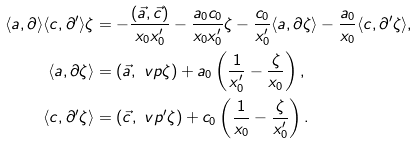<formula> <loc_0><loc_0><loc_500><loc_500>\langle a , \partial \rangle \langle c , \partial ^ { \prime } \rangle \zeta & = - \frac { ( \vec { a } , \vec { c } ) } { x _ { 0 } x ^ { \prime } _ { 0 } } - \frac { a _ { 0 } c _ { 0 } } { x _ { 0 } x ^ { \prime } _ { 0 } } \zeta - \frac { c _ { 0 } } { x ^ { \prime } _ { 0 } } \langle a , \partial \zeta \rangle - \frac { a _ { 0 } } { x _ { 0 } } \langle c , \partial ^ { \prime } \zeta \rangle , \\ \langle a , \partial \zeta \rangle & = ( \vec { a } , \ v p \zeta ) + a _ { 0 } \left ( \frac { 1 } { x _ { 0 } ^ { \prime } } - \frac { \zeta } { x _ { 0 } } \right ) , \\ \langle c , \partial ^ { \prime } \zeta \rangle & = ( \vec { c } , \ v p ^ { \prime } \zeta ) + c _ { 0 } \left ( \frac { 1 } { x _ { 0 } } - \frac { \zeta } { x _ { 0 } ^ { \prime } } \right ) .</formula> 